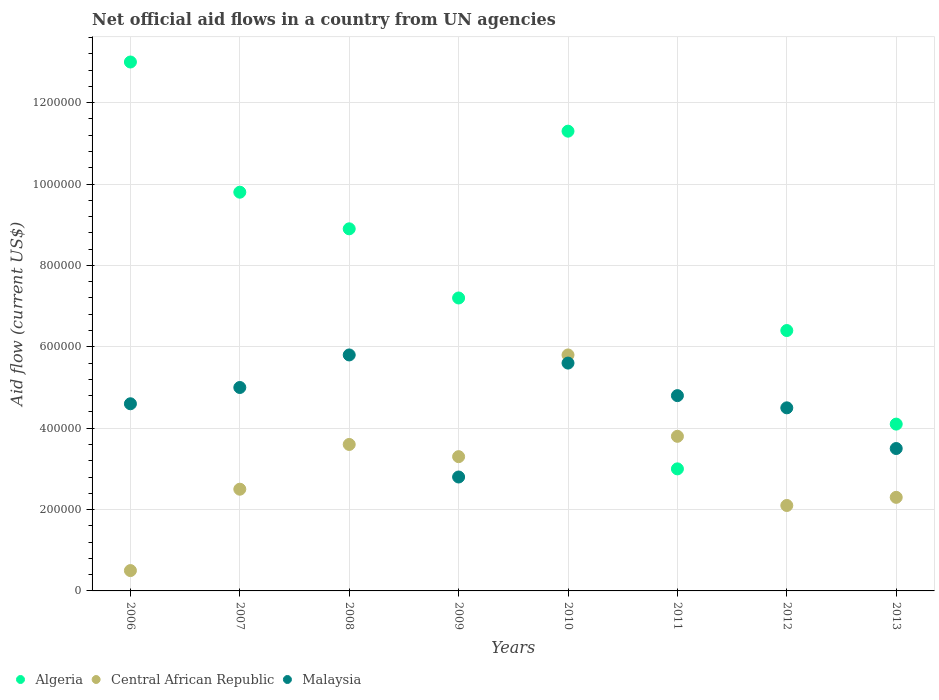Is the number of dotlines equal to the number of legend labels?
Your answer should be compact. Yes. What is the net official aid flow in Algeria in 2008?
Give a very brief answer. 8.90e+05. Across all years, what is the maximum net official aid flow in Algeria?
Give a very brief answer. 1.30e+06. Across all years, what is the minimum net official aid flow in Central African Republic?
Offer a very short reply. 5.00e+04. In which year was the net official aid flow in Central African Republic maximum?
Offer a very short reply. 2010. What is the total net official aid flow in Algeria in the graph?
Your answer should be very brief. 6.37e+06. What is the difference between the net official aid flow in Malaysia in 2007 and that in 2012?
Your answer should be compact. 5.00e+04. What is the difference between the net official aid flow in Algeria in 2009 and the net official aid flow in Malaysia in 2012?
Your answer should be very brief. 2.70e+05. What is the average net official aid flow in Central African Republic per year?
Give a very brief answer. 2.99e+05. In the year 2013, what is the difference between the net official aid flow in Malaysia and net official aid flow in Algeria?
Your answer should be compact. -6.00e+04. What is the ratio of the net official aid flow in Algeria in 2008 to that in 2013?
Give a very brief answer. 2.17. What is the difference between the highest and the second highest net official aid flow in Central African Republic?
Keep it short and to the point. 2.00e+05. What is the difference between the highest and the lowest net official aid flow in Central African Republic?
Your answer should be compact. 5.30e+05. Does the net official aid flow in Algeria monotonically increase over the years?
Provide a short and direct response. No. Is the net official aid flow in Central African Republic strictly greater than the net official aid flow in Malaysia over the years?
Make the answer very short. No. How many dotlines are there?
Provide a short and direct response. 3. How many years are there in the graph?
Your answer should be compact. 8. Are the values on the major ticks of Y-axis written in scientific E-notation?
Give a very brief answer. No. Does the graph contain grids?
Keep it short and to the point. Yes. Where does the legend appear in the graph?
Make the answer very short. Bottom left. What is the title of the graph?
Your response must be concise. Net official aid flows in a country from UN agencies. Does "Austria" appear as one of the legend labels in the graph?
Your answer should be very brief. No. What is the Aid flow (current US$) in Algeria in 2006?
Give a very brief answer. 1.30e+06. What is the Aid flow (current US$) in Malaysia in 2006?
Give a very brief answer. 4.60e+05. What is the Aid flow (current US$) in Algeria in 2007?
Your answer should be very brief. 9.80e+05. What is the Aid flow (current US$) in Malaysia in 2007?
Your answer should be compact. 5.00e+05. What is the Aid flow (current US$) in Algeria in 2008?
Offer a terse response. 8.90e+05. What is the Aid flow (current US$) in Malaysia in 2008?
Your response must be concise. 5.80e+05. What is the Aid flow (current US$) in Algeria in 2009?
Provide a succinct answer. 7.20e+05. What is the Aid flow (current US$) of Malaysia in 2009?
Your answer should be compact. 2.80e+05. What is the Aid flow (current US$) of Algeria in 2010?
Give a very brief answer. 1.13e+06. What is the Aid flow (current US$) of Central African Republic in 2010?
Offer a very short reply. 5.80e+05. What is the Aid flow (current US$) in Malaysia in 2010?
Your response must be concise. 5.60e+05. What is the Aid flow (current US$) of Algeria in 2012?
Make the answer very short. 6.40e+05. What is the Aid flow (current US$) of Central African Republic in 2012?
Make the answer very short. 2.10e+05. What is the Aid flow (current US$) of Central African Republic in 2013?
Your answer should be very brief. 2.30e+05. Across all years, what is the maximum Aid flow (current US$) in Algeria?
Your answer should be compact. 1.30e+06. Across all years, what is the maximum Aid flow (current US$) of Central African Republic?
Your response must be concise. 5.80e+05. Across all years, what is the maximum Aid flow (current US$) of Malaysia?
Provide a succinct answer. 5.80e+05. Across all years, what is the minimum Aid flow (current US$) in Algeria?
Make the answer very short. 3.00e+05. Across all years, what is the minimum Aid flow (current US$) in Central African Republic?
Keep it short and to the point. 5.00e+04. Across all years, what is the minimum Aid flow (current US$) in Malaysia?
Provide a short and direct response. 2.80e+05. What is the total Aid flow (current US$) of Algeria in the graph?
Your answer should be compact. 6.37e+06. What is the total Aid flow (current US$) of Central African Republic in the graph?
Your response must be concise. 2.39e+06. What is the total Aid flow (current US$) of Malaysia in the graph?
Offer a very short reply. 3.66e+06. What is the difference between the Aid flow (current US$) of Central African Republic in 2006 and that in 2008?
Your response must be concise. -3.10e+05. What is the difference between the Aid flow (current US$) in Malaysia in 2006 and that in 2008?
Offer a very short reply. -1.20e+05. What is the difference between the Aid flow (current US$) of Algeria in 2006 and that in 2009?
Your answer should be very brief. 5.80e+05. What is the difference between the Aid flow (current US$) of Central African Republic in 2006 and that in 2009?
Keep it short and to the point. -2.80e+05. What is the difference between the Aid flow (current US$) of Central African Republic in 2006 and that in 2010?
Provide a succinct answer. -5.30e+05. What is the difference between the Aid flow (current US$) of Central African Republic in 2006 and that in 2011?
Provide a succinct answer. -3.30e+05. What is the difference between the Aid flow (current US$) in Malaysia in 2006 and that in 2011?
Provide a succinct answer. -2.00e+04. What is the difference between the Aid flow (current US$) in Central African Republic in 2006 and that in 2012?
Give a very brief answer. -1.60e+05. What is the difference between the Aid flow (current US$) of Algeria in 2006 and that in 2013?
Make the answer very short. 8.90e+05. What is the difference between the Aid flow (current US$) in Central African Republic in 2006 and that in 2013?
Provide a short and direct response. -1.80e+05. What is the difference between the Aid flow (current US$) in Malaysia in 2006 and that in 2013?
Make the answer very short. 1.10e+05. What is the difference between the Aid flow (current US$) of Algeria in 2007 and that in 2008?
Your answer should be compact. 9.00e+04. What is the difference between the Aid flow (current US$) in Central African Republic in 2007 and that in 2008?
Provide a succinct answer. -1.10e+05. What is the difference between the Aid flow (current US$) of Algeria in 2007 and that in 2009?
Offer a very short reply. 2.60e+05. What is the difference between the Aid flow (current US$) in Malaysia in 2007 and that in 2009?
Your response must be concise. 2.20e+05. What is the difference between the Aid flow (current US$) of Algeria in 2007 and that in 2010?
Ensure brevity in your answer.  -1.50e+05. What is the difference between the Aid flow (current US$) of Central African Republic in 2007 and that in 2010?
Give a very brief answer. -3.30e+05. What is the difference between the Aid flow (current US$) in Algeria in 2007 and that in 2011?
Your response must be concise. 6.80e+05. What is the difference between the Aid flow (current US$) in Algeria in 2007 and that in 2012?
Ensure brevity in your answer.  3.40e+05. What is the difference between the Aid flow (current US$) of Algeria in 2007 and that in 2013?
Give a very brief answer. 5.70e+05. What is the difference between the Aid flow (current US$) of Central African Republic in 2007 and that in 2013?
Offer a terse response. 2.00e+04. What is the difference between the Aid flow (current US$) in Malaysia in 2007 and that in 2013?
Your answer should be compact. 1.50e+05. What is the difference between the Aid flow (current US$) of Central African Republic in 2008 and that in 2009?
Offer a very short reply. 3.00e+04. What is the difference between the Aid flow (current US$) in Malaysia in 2008 and that in 2009?
Provide a succinct answer. 3.00e+05. What is the difference between the Aid flow (current US$) in Algeria in 2008 and that in 2010?
Provide a succinct answer. -2.40e+05. What is the difference between the Aid flow (current US$) of Central African Republic in 2008 and that in 2010?
Your answer should be compact. -2.20e+05. What is the difference between the Aid flow (current US$) of Algeria in 2008 and that in 2011?
Keep it short and to the point. 5.90e+05. What is the difference between the Aid flow (current US$) of Malaysia in 2008 and that in 2011?
Provide a succinct answer. 1.00e+05. What is the difference between the Aid flow (current US$) in Malaysia in 2008 and that in 2012?
Your answer should be compact. 1.30e+05. What is the difference between the Aid flow (current US$) of Central African Republic in 2008 and that in 2013?
Your answer should be compact. 1.30e+05. What is the difference between the Aid flow (current US$) of Malaysia in 2008 and that in 2013?
Keep it short and to the point. 2.30e+05. What is the difference between the Aid flow (current US$) of Algeria in 2009 and that in 2010?
Provide a short and direct response. -4.10e+05. What is the difference between the Aid flow (current US$) in Malaysia in 2009 and that in 2010?
Ensure brevity in your answer.  -2.80e+05. What is the difference between the Aid flow (current US$) in Central African Republic in 2009 and that in 2011?
Make the answer very short. -5.00e+04. What is the difference between the Aid flow (current US$) of Algeria in 2009 and that in 2012?
Keep it short and to the point. 8.00e+04. What is the difference between the Aid flow (current US$) in Algeria in 2009 and that in 2013?
Ensure brevity in your answer.  3.10e+05. What is the difference between the Aid flow (current US$) in Algeria in 2010 and that in 2011?
Ensure brevity in your answer.  8.30e+05. What is the difference between the Aid flow (current US$) in Central African Republic in 2010 and that in 2011?
Provide a short and direct response. 2.00e+05. What is the difference between the Aid flow (current US$) in Central African Republic in 2010 and that in 2012?
Make the answer very short. 3.70e+05. What is the difference between the Aid flow (current US$) of Algeria in 2010 and that in 2013?
Your response must be concise. 7.20e+05. What is the difference between the Aid flow (current US$) of Central African Republic in 2010 and that in 2013?
Your answer should be compact. 3.50e+05. What is the difference between the Aid flow (current US$) of Malaysia in 2010 and that in 2013?
Your response must be concise. 2.10e+05. What is the difference between the Aid flow (current US$) in Algeria in 2011 and that in 2012?
Your response must be concise. -3.40e+05. What is the difference between the Aid flow (current US$) of Malaysia in 2011 and that in 2012?
Provide a succinct answer. 3.00e+04. What is the difference between the Aid flow (current US$) in Central African Republic in 2011 and that in 2013?
Give a very brief answer. 1.50e+05. What is the difference between the Aid flow (current US$) of Malaysia in 2011 and that in 2013?
Your answer should be very brief. 1.30e+05. What is the difference between the Aid flow (current US$) in Central African Republic in 2012 and that in 2013?
Provide a succinct answer. -2.00e+04. What is the difference between the Aid flow (current US$) of Algeria in 2006 and the Aid flow (current US$) of Central African Republic in 2007?
Make the answer very short. 1.05e+06. What is the difference between the Aid flow (current US$) of Central African Republic in 2006 and the Aid flow (current US$) of Malaysia in 2007?
Offer a very short reply. -4.50e+05. What is the difference between the Aid flow (current US$) in Algeria in 2006 and the Aid flow (current US$) in Central African Republic in 2008?
Your answer should be compact. 9.40e+05. What is the difference between the Aid flow (current US$) of Algeria in 2006 and the Aid flow (current US$) of Malaysia in 2008?
Your answer should be very brief. 7.20e+05. What is the difference between the Aid flow (current US$) of Central African Republic in 2006 and the Aid flow (current US$) of Malaysia in 2008?
Provide a short and direct response. -5.30e+05. What is the difference between the Aid flow (current US$) in Algeria in 2006 and the Aid flow (current US$) in Central African Republic in 2009?
Your response must be concise. 9.70e+05. What is the difference between the Aid flow (current US$) in Algeria in 2006 and the Aid flow (current US$) in Malaysia in 2009?
Give a very brief answer. 1.02e+06. What is the difference between the Aid flow (current US$) of Algeria in 2006 and the Aid flow (current US$) of Central African Republic in 2010?
Provide a succinct answer. 7.20e+05. What is the difference between the Aid flow (current US$) in Algeria in 2006 and the Aid flow (current US$) in Malaysia in 2010?
Offer a terse response. 7.40e+05. What is the difference between the Aid flow (current US$) of Central African Republic in 2006 and the Aid flow (current US$) of Malaysia in 2010?
Offer a very short reply. -5.10e+05. What is the difference between the Aid flow (current US$) in Algeria in 2006 and the Aid flow (current US$) in Central African Republic in 2011?
Your answer should be compact. 9.20e+05. What is the difference between the Aid flow (current US$) in Algeria in 2006 and the Aid flow (current US$) in Malaysia in 2011?
Make the answer very short. 8.20e+05. What is the difference between the Aid flow (current US$) of Central African Republic in 2006 and the Aid flow (current US$) of Malaysia in 2011?
Ensure brevity in your answer.  -4.30e+05. What is the difference between the Aid flow (current US$) in Algeria in 2006 and the Aid flow (current US$) in Central African Republic in 2012?
Ensure brevity in your answer.  1.09e+06. What is the difference between the Aid flow (current US$) in Algeria in 2006 and the Aid flow (current US$) in Malaysia in 2012?
Make the answer very short. 8.50e+05. What is the difference between the Aid flow (current US$) of Central African Republic in 2006 and the Aid flow (current US$) of Malaysia in 2012?
Provide a short and direct response. -4.00e+05. What is the difference between the Aid flow (current US$) of Algeria in 2006 and the Aid flow (current US$) of Central African Republic in 2013?
Your answer should be very brief. 1.07e+06. What is the difference between the Aid flow (current US$) in Algeria in 2006 and the Aid flow (current US$) in Malaysia in 2013?
Offer a very short reply. 9.50e+05. What is the difference between the Aid flow (current US$) in Algeria in 2007 and the Aid flow (current US$) in Central African Republic in 2008?
Your response must be concise. 6.20e+05. What is the difference between the Aid flow (current US$) of Algeria in 2007 and the Aid flow (current US$) of Malaysia in 2008?
Your answer should be very brief. 4.00e+05. What is the difference between the Aid flow (current US$) in Central African Republic in 2007 and the Aid flow (current US$) in Malaysia in 2008?
Give a very brief answer. -3.30e+05. What is the difference between the Aid flow (current US$) of Algeria in 2007 and the Aid flow (current US$) of Central African Republic in 2009?
Offer a very short reply. 6.50e+05. What is the difference between the Aid flow (current US$) of Algeria in 2007 and the Aid flow (current US$) of Central African Republic in 2010?
Keep it short and to the point. 4.00e+05. What is the difference between the Aid flow (current US$) in Algeria in 2007 and the Aid flow (current US$) in Malaysia in 2010?
Offer a very short reply. 4.20e+05. What is the difference between the Aid flow (current US$) of Central African Republic in 2007 and the Aid flow (current US$) of Malaysia in 2010?
Keep it short and to the point. -3.10e+05. What is the difference between the Aid flow (current US$) in Algeria in 2007 and the Aid flow (current US$) in Central African Republic in 2012?
Your answer should be very brief. 7.70e+05. What is the difference between the Aid flow (current US$) in Algeria in 2007 and the Aid flow (current US$) in Malaysia in 2012?
Your answer should be very brief. 5.30e+05. What is the difference between the Aid flow (current US$) in Algeria in 2007 and the Aid flow (current US$) in Central African Republic in 2013?
Provide a short and direct response. 7.50e+05. What is the difference between the Aid flow (current US$) in Algeria in 2007 and the Aid flow (current US$) in Malaysia in 2013?
Provide a succinct answer. 6.30e+05. What is the difference between the Aid flow (current US$) in Algeria in 2008 and the Aid flow (current US$) in Central African Republic in 2009?
Your answer should be very brief. 5.60e+05. What is the difference between the Aid flow (current US$) in Algeria in 2008 and the Aid flow (current US$) in Malaysia in 2010?
Make the answer very short. 3.30e+05. What is the difference between the Aid flow (current US$) of Algeria in 2008 and the Aid flow (current US$) of Central African Republic in 2011?
Your response must be concise. 5.10e+05. What is the difference between the Aid flow (current US$) of Central African Republic in 2008 and the Aid flow (current US$) of Malaysia in 2011?
Keep it short and to the point. -1.20e+05. What is the difference between the Aid flow (current US$) in Algeria in 2008 and the Aid flow (current US$) in Central African Republic in 2012?
Keep it short and to the point. 6.80e+05. What is the difference between the Aid flow (current US$) in Algeria in 2008 and the Aid flow (current US$) in Central African Republic in 2013?
Provide a succinct answer. 6.60e+05. What is the difference between the Aid flow (current US$) of Algeria in 2008 and the Aid flow (current US$) of Malaysia in 2013?
Make the answer very short. 5.40e+05. What is the difference between the Aid flow (current US$) of Central African Republic in 2008 and the Aid flow (current US$) of Malaysia in 2013?
Keep it short and to the point. 10000. What is the difference between the Aid flow (current US$) of Algeria in 2009 and the Aid flow (current US$) of Malaysia in 2010?
Ensure brevity in your answer.  1.60e+05. What is the difference between the Aid flow (current US$) in Algeria in 2009 and the Aid flow (current US$) in Malaysia in 2011?
Offer a terse response. 2.40e+05. What is the difference between the Aid flow (current US$) of Central African Republic in 2009 and the Aid flow (current US$) of Malaysia in 2011?
Ensure brevity in your answer.  -1.50e+05. What is the difference between the Aid flow (current US$) in Algeria in 2009 and the Aid flow (current US$) in Central African Republic in 2012?
Offer a very short reply. 5.10e+05. What is the difference between the Aid flow (current US$) in Algeria in 2009 and the Aid flow (current US$) in Malaysia in 2012?
Keep it short and to the point. 2.70e+05. What is the difference between the Aid flow (current US$) of Algeria in 2009 and the Aid flow (current US$) of Central African Republic in 2013?
Provide a succinct answer. 4.90e+05. What is the difference between the Aid flow (current US$) of Algeria in 2009 and the Aid flow (current US$) of Malaysia in 2013?
Give a very brief answer. 3.70e+05. What is the difference between the Aid flow (current US$) in Algeria in 2010 and the Aid flow (current US$) in Central African Republic in 2011?
Offer a very short reply. 7.50e+05. What is the difference between the Aid flow (current US$) in Algeria in 2010 and the Aid flow (current US$) in Malaysia in 2011?
Your answer should be compact. 6.50e+05. What is the difference between the Aid flow (current US$) of Algeria in 2010 and the Aid flow (current US$) of Central African Republic in 2012?
Give a very brief answer. 9.20e+05. What is the difference between the Aid flow (current US$) of Algeria in 2010 and the Aid flow (current US$) of Malaysia in 2012?
Offer a terse response. 6.80e+05. What is the difference between the Aid flow (current US$) in Algeria in 2010 and the Aid flow (current US$) in Malaysia in 2013?
Your answer should be compact. 7.80e+05. What is the difference between the Aid flow (current US$) of Algeria in 2011 and the Aid flow (current US$) of Central African Republic in 2012?
Offer a very short reply. 9.00e+04. What is the difference between the Aid flow (current US$) in Algeria in 2011 and the Aid flow (current US$) in Malaysia in 2012?
Give a very brief answer. -1.50e+05. What is the difference between the Aid flow (current US$) of Algeria in 2011 and the Aid flow (current US$) of Malaysia in 2013?
Provide a succinct answer. -5.00e+04. What is the difference between the Aid flow (current US$) of Central African Republic in 2011 and the Aid flow (current US$) of Malaysia in 2013?
Keep it short and to the point. 3.00e+04. What is the difference between the Aid flow (current US$) of Algeria in 2012 and the Aid flow (current US$) of Central African Republic in 2013?
Give a very brief answer. 4.10e+05. What is the difference between the Aid flow (current US$) in Algeria in 2012 and the Aid flow (current US$) in Malaysia in 2013?
Give a very brief answer. 2.90e+05. What is the average Aid flow (current US$) of Algeria per year?
Offer a very short reply. 7.96e+05. What is the average Aid flow (current US$) of Central African Republic per year?
Provide a short and direct response. 2.99e+05. What is the average Aid flow (current US$) of Malaysia per year?
Ensure brevity in your answer.  4.58e+05. In the year 2006, what is the difference between the Aid flow (current US$) of Algeria and Aid flow (current US$) of Central African Republic?
Offer a very short reply. 1.25e+06. In the year 2006, what is the difference between the Aid flow (current US$) of Algeria and Aid flow (current US$) of Malaysia?
Your answer should be very brief. 8.40e+05. In the year 2006, what is the difference between the Aid flow (current US$) of Central African Republic and Aid flow (current US$) of Malaysia?
Make the answer very short. -4.10e+05. In the year 2007, what is the difference between the Aid flow (current US$) in Algeria and Aid flow (current US$) in Central African Republic?
Provide a succinct answer. 7.30e+05. In the year 2007, what is the difference between the Aid flow (current US$) in Central African Republic and Aid flow (current US$) in Malaysia?
Provide a succinct answer. -2.50e+05. In the year 2008, what is the difference between the Aid flow (current US$) in Algeria and Aid flow (current US$) in Central African Republic?
Make the answer very short. 5.30e+05. In the year 2009, what is the difference between the Aid flow (current US$) in Algeria and Aid flow (current US$) in Malaysia?
Your response must be concise. 4.40e+05. In the year 2010, what is the difference between the Aid flow (current US$) in Algeria and Aid flow (current US$) in Central African Republic?
Provide a short and direct response. 5.50e+05. In the year 2010, what is the difference between the Aid flow (current US$) of Algeria and Aid flow (current US$) of Malaysia?
Offer a terse response. 5.70e+05. In the year 2010, what is the difference between the Aid flow (current US$) in Central African Republic and Aid flow (current US$) in Malaysia?
Provide a succinct answer. 2.00e+04. In the year 2011, what is the difference between the Aid flow (current US$) of Algeria and Aid flow (current US$) of Malaysia?
Provide a short and direct response. -1.80e+05. In the year 2011, what is the difference between the Aid flow (current US$) of Central African Republic and Aid flow (current US$) of Malaysia?
Your response must be concise. -1.00e+05. In the year 2012, what is the difference between the Aid flow (current US$) of Algeria and Aid flow (current US$) of Malaysia?
Ensure brevity in your answer.  1.90e+05. In the year 2013, what is the difference between the Aid flow (current US$) in Algeria and Aid flow (current US$) in Central African Republic?
Your answer should be compact. 1.80e+05. What is the ratio of the Aid flow (current US$) in Algeria in 2006 to that in 2007?
Provide a short and direct response. 1.33. What is the ratio of the Aid flow (current US$) of Central African Republic in 2006 to that in 2007?
Offer a terse response. 0.2. What is the ratio of the Aid flow (current US$) in Malaysia in 2006 to that in 2007?
Give a very brief answer. 0.92. What is the ratio of the Aid flow (current US$) of Algeria in 2006 to that in 2008?
Give a very brief answer. 1.46. What is the ratio of the Aid flow (current US$) of Central African Republic in 2006 to that in 2008?
Offer a very short reply. 0.14. What is the ratio of the Aid flow (current US$) of Malaysia in 2006 to that in 2008?
Your response must be concise. 0.79. What is the ratio of the Aid flow (current US$) of Algeria in 2006 to that in 2009?
Your answer should be very brief. 1.81. What is the ratio of the Aid flow (current US$) of Central African Republic in 2006 to that in 2009?
Your answer should be very brief. 0.15. What is the ratio of the Aid flow (current US$) in Malaysia in 2006 to that in 2009?
Make the answer very short. 1.64. What is the ratio of the Aid flow (current US$) of Algeria in 2006 to that in 2010?
Your answer should be very brief. 1.15. What is the ratio of the Aid flow (current US$) of Central African Republic in 2006 to that in 2010?
Provide a succinct answer. 0.09. What is the ratio of the Aid flow (current US$) of Malaysia in 2006 to that in 2010?
Keep it short and to the point. 0.82. What is the ratio of the Aid flow (current US$) in Algeria in 2006 to that in 2011?
Your answer should be very brief. 4.33. What is the ratio of the Aid flow (current US$) of Central African Republic in 2006 to that in 2011?
Provide a succinct answer. 0.13. What is the ratio of the Aid flow (current US$) in Malaysia in 2006 to that in 2011?
Provide a short and direct response. 0.96. What is the ratio of the Aid flow (current US$) of Algeria in 2006 to that in 2012?
Your response must be concise. 2.03. What is the ratio of the Aid flow (current US$) of Central African Republic in 2006 to that in 2012?
Make the answer very short. 0.24. What is the ratio of the Aid flow (current US$) of Malaysia in 2006 to that in 2012?
Your response must be concise. 1.02. What is the ratio of the Aid flow (current US$) in Algeria in 2006 to that in 2013?
Keep it short and to the point. 3.17. What is the ratio of the Aid flow (current US$) in Central African Republic in 2006 to that in 2013?
Your answer should be very brief. 0.22. What is the ratio of the Aid flow (current US$) in Malaysia in 2006 to that in 2013?
Your answer should be very brief. 1.31. What is the ratio of the Aid flow (current US$) of Algeria in 2007 to that in 2008?
Your response must be concise. 1.1. What is the ratio of the Aid flow (current US$) in Central African Republic in 2007 to that in 2008?
Keep it short and to the point. 0.69. What is the ratio of the Aid flow (current US$) of Malaysia in 2007 to that in 2008?
Provide a succinct answer. 0.86. What is the ratio of the Aid flow (current US$) in Algeria in 2007 to that in 2009?
Your answer should be compact. 1.36. What is the ratio of the Aid flow (current US$) in Central African Republic in 2007 to that in 2009?
Give a very brief answer. 0.76. What is the ratio of the Aid flow (current US$) in Malaysia in 2007 to that in 2009?
Offer a terse response. 1.79. What is the ratio of the Aid flow (current US$) in Algeria in 2007 to that in 2010?
Offer a very short reply. 0.87. What is the ratio of the Aid flow (current US$) in Central African Republic in 2007 to that in 2010?
Keep it short and to the point. 0.43. What is the ratio of the Aid flow (current US$) in Malaysia in 2007 to that in 2010?
Provide a succinct answer. 0.89. What is the ratio of the Aid flow (current US$) of Algeria in 2007 to that in 2011?
Ensure brevity in your answer.  3.27. What is the ratio of the Aid flow (current US$) of Central African Republic in 2007 to that in 2011?
Your answer should be very brief. 0.66. What is the ratio of the Aid flow (current US$) of Malaysia in 2007 to that in 2011?
Your answer should be compact. 1.04. What is the ratio of the Aid flow (current US$) of Algeria in 2007 to that in 2012?
Your answer should be very brief. 1.53. What is the ratio of the Aid flow (current US$) of Central African Republic in 2007 to that in 2012?
Ensure brevity in your answer.  1.19. What is the ratio of the Aid flow (current US$) of Algeria in 2007 to that in 2013?
Offer a very short reply. 2.39. What is the ratio of the Aid flow (current US$) in Central African Republic in 2007 to that in 2013?
Give a very brief answer. 1.09. What is the ratio of the Aid flow (current US$) in Malaysia in 2007 to that in 2013?
Your answer should be compact. 1.43. What is the ratio of the Aid flow (current US$) in Algeria in 2008 to that in 2009?
Your answer should be compact. 1.24. What is the ratio of the Aid flow (current US$) of Malaysia in 2008 to that in 2009?
Your response must be concise. 2.07. What is the ratio of the Aid flow (current US$) in Algeria in 2008 to that in 2010?
Your response must be concise. 0.79. What is the ratio of the Aid flow (current US$) in Central African Republic in 2008 to that in 2010?
Provide a succinct answer. 0.62. What is the ratio of the Aid flow (current US$) in Malaysia in 2008 to that in 2010?
Provide a succinct answer. 1.04. What is the ratio of the Aid flow (current US$) in Algeria in 2008 to that in 2011?
Keep it short and to the point. 2.97. What is the ratio of the Aid flow (current US$) of Malaysia in 2008 to that in 2011?
Ensure brevity in your answer.  1.21. What is the ratio of the Aid flow (current US$) of Algeria in 2008 to that in 2012?
Provide a succinct answer. 1.39. What is the ratio of the Aid flow (current US$) in Central African Republic in 2008 to that in 2012?
Provide a succinct answer. 1.71. What is the ratio of the Aid flow (current US$) in Malaysia in 2008 to that in 2012?
Keep it short and to the point. 1.29. What is the ratio of the Aid flow (current US$) in Algeria in 2008 to that in 2013?
Your response must be concise. 2.17. What is the ratio of the Aid flow (current US$) of Central African Republic in 2008 to that in 2013?
Give a very brief answer. 1.57. What is the ratio of the Aid flow (current US$) in Malaysia in 2008 to that in 2013?
Ensure brevity in your answer.  1.66. What is the ratio of the Aid flow (current US$) in Algeria in 2009 to that in 2010?
Offer a terse response. 0.64. What is the ratio of the Aid flow (current US$) of Central African Republic in 2009 to that in 2010?
Your response must be concise. 0.57. What is the ratio of the Aid flow (current US$) in Malaysia in 2009 to that in 2010?
Your response must be concise. 0.5. What is the ratio of the Aid flow (current US$) of Algeria in 2009 to that in 2011?
Provide a succinct answer. 2.4. What is the ratio of the Aid flow (current US$) in Central African Republic in 2009 to that in 2011?
Give a very brief answer. 0.87. What is the ratio of the Aid flow (current US$) of Malaysia in 2009 to that in 2011?
Your answer should be compact. 0.58. What is the ratio of the Aid flow (current US$) in Central African Republic in 2009 to that in 2012?
Offer a terse response. 1.57. What is the ratio of the Aid flow (current US$) of Malaysia in 2009 to that in 2012?
Keep it short and to the point. 0.62. What is the ratio of the Aid flow (current US$) in Algeria in 2009 to that in 2013?
Your answer should be compact. 1.76. What is the ratio of the Aid flow (current US$) in Central African Republic in 2009 to that in 2013?
Give a very brief answer. 1.43. What is the ratio of the Aid flow (current US$) in Malaysia in 2009 to that in 2013?
Offer a terse response. 0.8. What is the ratio of the Aid flow (current US$) in Algeria in 2010 to that in 2011?
Give a very brief answer. 3.77. What is the ratio of the Aid flow (current US$) in Central African Republic in 2010 to that in 2011?
Your response must be concise. 1.53. What is the ratio of the Aid flow (current US$) in Malaysia in 2010 to that in 2011?
Offer a very short reply. 1.17. What is the ratio of the Aid flow (current US$) in Algeria in 2010 to that in 2012?
Offer a terse response. 1.77. What is the ratio of the Aid flow (current US$) in Central African Republic in 2010 to that in 2012?
Provide a succinct answer. 2.76. What is the ratio of the Aid flow (current US$) in Malaysia in 2010 to that in 2012?
Provide a short and direct response. 1.24. What is the ratio of the Aid flow (current US$) of Algeria in 2010 to that in 2013?
Ensure brevity in your answer.  2.76. What is the ratio of the Aid flow (current US$) of Central African Republic in 2010 to that in 2013?
Provide a succinct answer. 2.52. What is the ratio of the Aid flow (current US$) of Malaysia in 2010 to that in 2013?
Your answer should be very brief. 1.6. What is the ratio of the Aid flow (current US$) in Algeria in 2011 to that in 2012?
Provide a short and direct response. 0.47. What is the ratio of the Aid flow (current US$) in Central African Republic in 2011 to that in 2012?
Provide a succinct answer. 1.81. What is the ratio of the Aid flow (current US$) in Malaysia in 2011 to that in 2012?
Make the answer very short. 1.07. What is the ratio of the Aid flow (current US$) in Algeria in 2011 to that in 2013?
Your answer should be very brief. 0.73. What is the ratio of the Aid flow (current US$) in Central African Republic in 2011 to that in 2013?
Make the answer very short. 1.65. What is the ratio of the Aid flow (current US$) of Malaysia in 2011 to that in 2013?
Provide a short and direct response. 1.37. What is the ratio of the Aid flow (current US$) in Algeria in 2012 to that in 2013?
Your answer should be compact. 1.56. What is the ratio of the Aid flow (current US$) in Central African Republic in 2012 to that in 2013?
Offer a terse response. 0.91. What is the difference between the highest and the lowest Aid flow (current US$) in Algeria?
Ensure brevity in your answer.  1.00e+06. What is the difference between the highest and the lowest Aid flow (current US$) of Central African Republic?
Ensure brevity in your answer.  5.30e+05. 